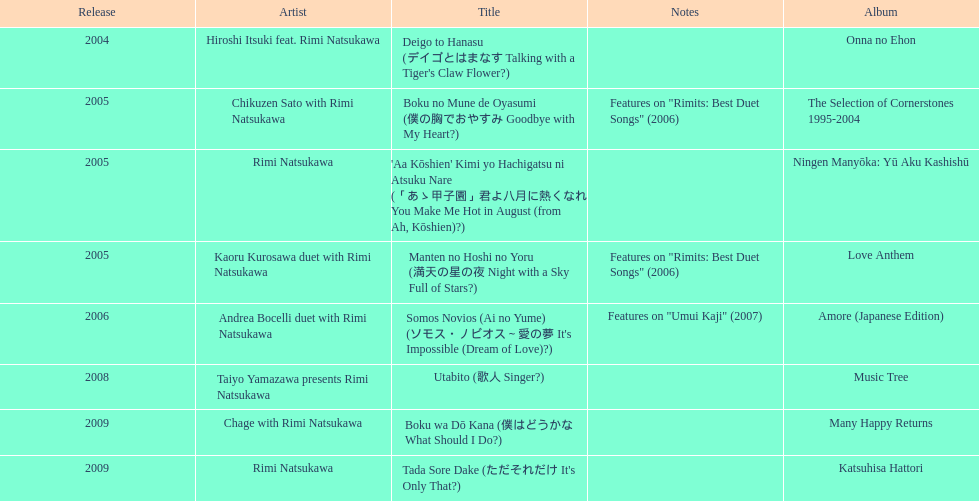How many other appearance did this artist make in 2005? 3. 